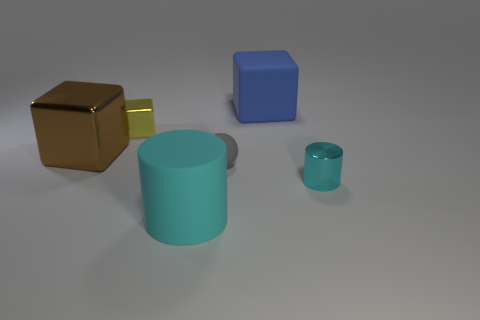The other cylinder that is the same color as the large cylinder is what size?
Your response must be concise. Small. Are there any other big cylinders that have the same color as the metallic cylinder?
Ensure brevity in your answer.  Yes. What is the color of the cylinder that is the same size as the yellow metallic cube?
Your response must be concise. Cyan. What material is the cylinder in front of the cylinder that is behind the big object in front of the small metal cylinder?
Offer a terse response. Rubber. Do the big rubber cylinder and the small shiny thing in front of the large shiny block have the same color?
Provide a succinct answer. Yes. What number of objects are either things that are behind the big brown metal thing or cyan objects that are to the left of the small cyan metallic thing?
Offer a terse response. 3. The big rubber object behind the matte object in front of the tiny gray ball is what shape?
Your answer should be compact. Cube. Are there any large brown objects made of the same material as the yellow block?
Ensure brevity in your answer.  Yes. There is another tiny object that is the same shape as the blue matte object; what is its color?
Your answer should be very brief. Yellow. Is the number of matte cylinders behind the big metal block less than the number of brown cubes that are in front of the big cyan cylinder?
Your answer should be very brief. No. 